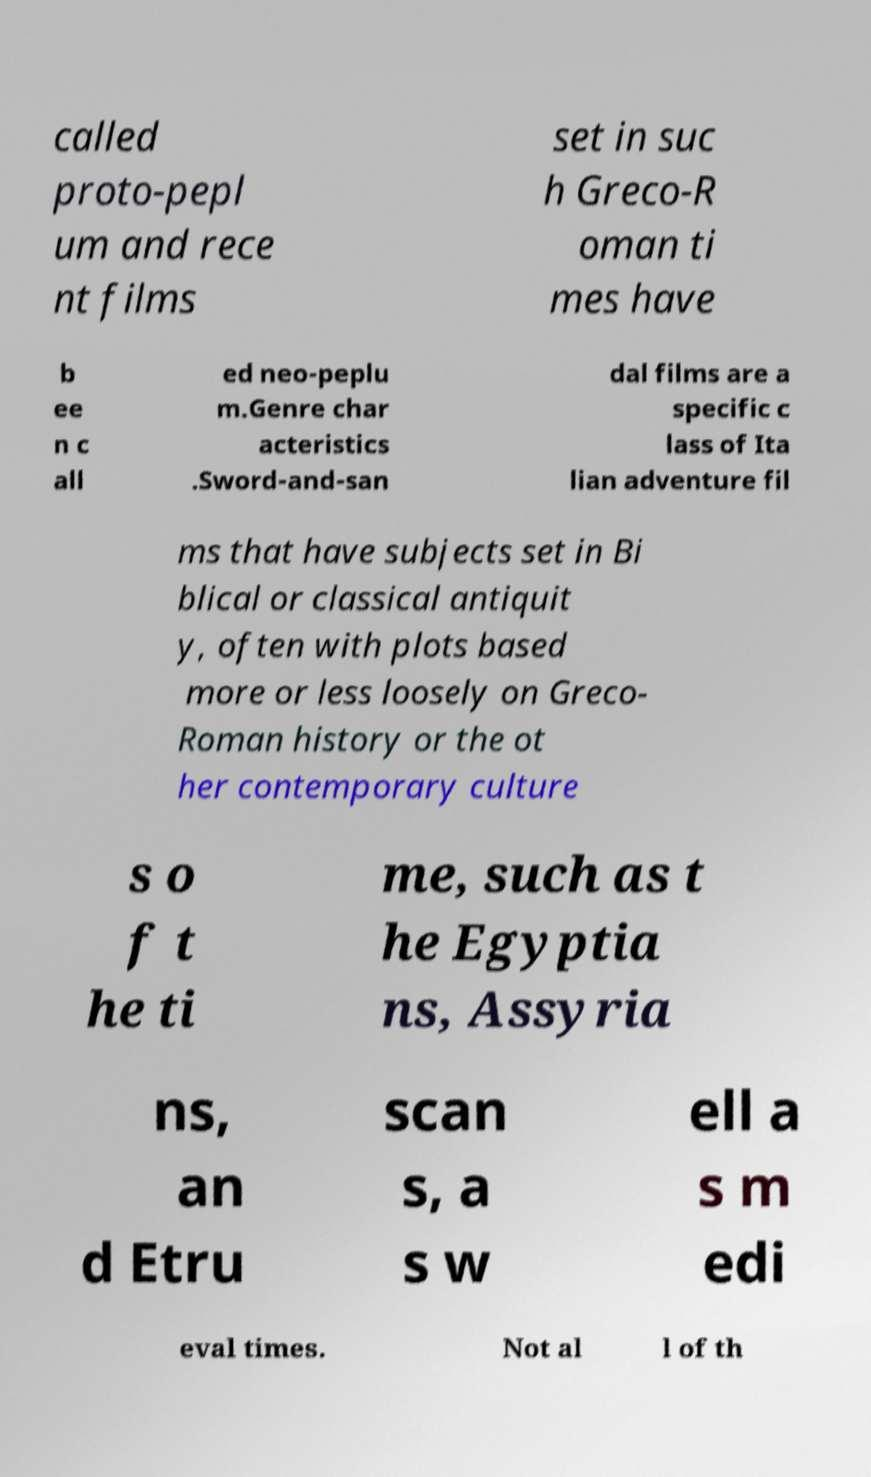There's text embedded in this image that I need extracted. Can you transcribe it verbatim? called proto-pepl um and rece nt films set in suc h Greco-R oman ti mes have b ee n c all ed neo-peplu m.Genre char acteristics .Sword-and-san dal films are a specific c lass of Ita lian adventure fil ms that have subjects set in Bi blical or classical antiquit y, often with plots based more or less loosely on Greco- Roman history or the ot her contemporary culture s o f t he ti me, such as t he Egyptia ns, Assyria ns, an d Etru scan s, a s w ell a s m edi eval times. Not al l of th 